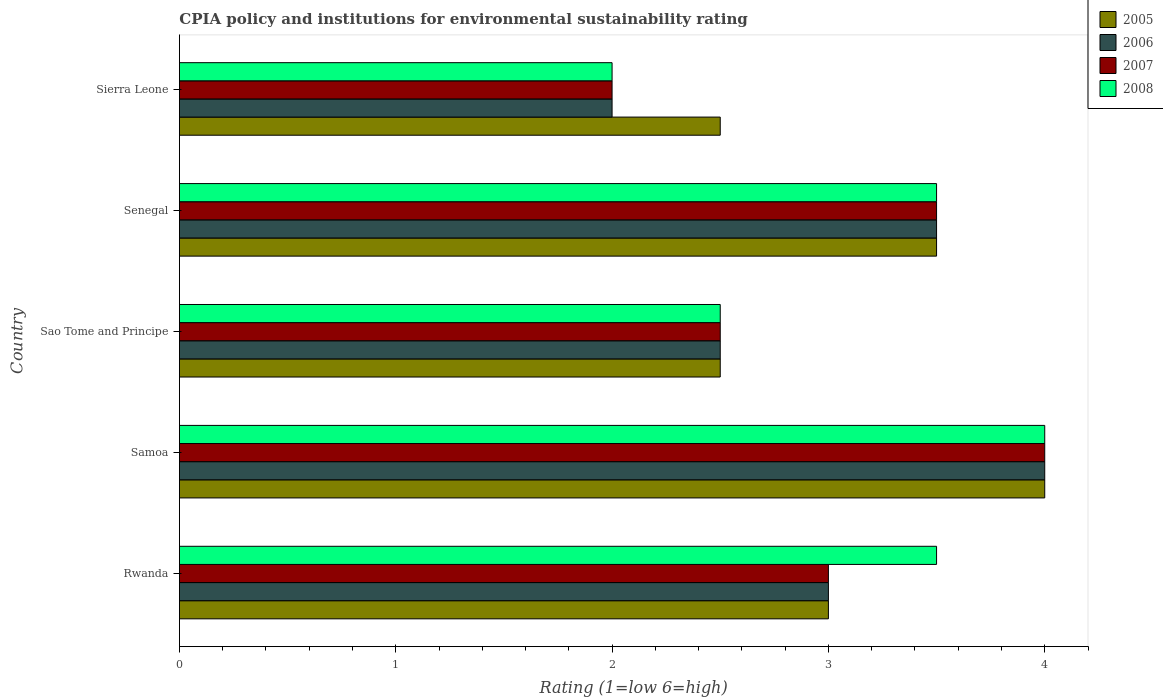How many bars are there on the 3rd tick from the bottom?
Give a very brief answer. 4. What is the label of the 2nd group of bars from the top?
Ensure brevity in your answer.  Senegal. What is the CPIA rating in 2008 in Sierra Leone?
Make the answer very short. 2. Across all countries, what is the maximum CPIA rating in 2008?
Provide a short and direct response. 4. In which country was the CPIA rating in 2007 maximum?
Keep it short and to the point. Samoa. In which country was the CPIA rating in 2006 minimum?
Your answer should be compact. Sierra Leone. What is the average CPIA rating in 2007 per country?
Provide a short and direct response. 3. What is the difference between the CPIA rating in 2005 and CPIA rating in 2008 in Rwanda?
Give a very brief answer. -0.5. In how many countries, is the CPIA rating in 2005 greater than 3.2 ?
Offer a terse response. 2. What is the difference between the highest and the second highest CPIA rating in 2008?
Make the answer very short. 0.5. What is the difference between the highest and the lowest CPIA rating in 2008?
Give a very brief answer. 2. In how many countries, is the CPIA rating in 2005 greater than the average CPIA rating in 2005 taken over all countries?
Provide a short and direct response. 2. Is the sum of the CPIA rating in 2006 in Rwanda and Samoa greater than the maximum CPIA rating in 2008 across all countries?
Make the answer very short. Yes. Is it the case that in every country, the sum of the CPIA rating in 2006 and CPIA rating in 2008 is greater than the sum of CPIA rating in 2007 and CPIA rating in 2005?
Offer a very short reply. No. Is it the case that in every country, the sum of the CPIA rating in 2007 and CPIA rating in 2006 is greater than the CPIA rating in 2005?
Provide a succinct answer. Yes. Are all the bars in the graph horizontal?
Offer a terse response. Yes. How many countries are there in the graph?
Your response must be concise. 5. What is the difference between two consecutive major ticks on the X-axis?
Keep it short and to the point. 1. Are the values on the major ticks of X-axis written in scientific E-notation?
Your answer should be very brief. No. Does the graph contain grids?
Ensure brevity in your answer.  No. Where does the legend appear in the graph?
Ensure brevity in your answer.  Top right. How many legend labels are there?
Ensure brevity in your answer.  4. How are the legend labels stacked?
Your response must be concise. Vertical. What is the title of the graph?
Provide a succinct answer. CPIA policy and institutions for environmental sustainability rating. Does "2015" appear as one of the legend labels in the graph?
Offer a very short reply. No. What is the label or title of the Y-axis?
Your answer should be very brief. Country. What is the Rating (1=low 6=high) of 2005 in Rwanda?
Give a very brief answer. 3. What is the Rating (1=low 6=high) of 2007 in Rwanda?
Keep it short and to the point. 3. What is the Rating (1=low 6=high) in 2008 in Rwanda?
Provide a succinct answer. 3.5. What is the Rating (1=low 6=high) in 2005 in Samoa?
Ensure brevity in your answer.  4. What is the Rating (1=low 6=high) in 2008 in Samoa?
Provide a succinct answer. 4. What is the Rating (1=low 6=high) in 2007 in Sao Tome and Principe?
Give a very brief answer. 2.5. What is the Rating (1=low 6=high) of 2006 in Senegal?
Your response must be concise. 3.5. What is the Rating (1=low 6=high) of 2007 in Senegal?
Your answer should be compact. 3.5. What is the Rating (1=low 6=high) in 2006 in Sierra Leone?
Offer a terse response. 2. Across all countries, what is the maximum Rating (1=low 6=high) in 2005?
Your response must be concise. 4. Across all countries, what is the maximum Rating (1=low 6=high) of 2007?
Provide a succinct answer. 4. Across all countries, what is the maximum Rating (1=low 6=high) of 2008?
Provide a short and direct response. 4. Across all countries, what is the minimum Rating (1=low 6=high) in 2005?
Your answer should be compact. 2.5. Across all countries, what is the minimum Rating (1=low 6=high) in 2006?
Keep it short and to the point. 2. Across all countries, what is the minimum Rating (1=low 6=high) in 2008?
Keep it short and to the point. 2. What is the total Rating (1=low 6=high) of 2006 in the graph?
Your answer should be compact. 15. What is the total Rating (1=low 6=high) in 2007 in the graph?
Provide a short and direct response. 15. What is the total Rating (1=low 6=high) in 2008 in the graph?
Your response must be concise. 15.5. What is the difference between the Rating (1=low 6=high) in 2006 in Rwanda and that in Samoa?
Your response must be concise. -1. What is the difference between the Rating (1=low 6=high) of 2007 in Rwanda and that in Sao Tome and Principe?
Provide a short and direct response. 0.5. What is the difference between the Rating (1=low 6=high) in 2008 in Rwanda and that in Sao Tome and Principe?
Ensure brevity in your answer.  1. What is the difference between the Rating (1=low 6=high) of 2007 in Rwanda and that in Senegal?
Ensure brevity in your answer.  -0.5. What is the difference between the Rating (1=low 6=high) of 2008 in Rwanda and that in Senegal?
Keep it short and to the point. 0. What is the difference between the Rating (1=low 6=high) of 2005 in Samoa and that in Sao Tome and Principe?
Keep it short and to the point. 1.5. What is the difference between the Rating (1=low 6=high) in 2007 in Samoa and that in Sao Tome and Principe?
Give a very brief answer. 1.5. What is the difference between the Rating (1=low 6=high) in 2005 in Samoa and that in Senegal?
Keep it short and to the point. 0.5. What is the difference between the Rating (1=low 6=high) in 2006 in Samoa and that in Senegal?
Give a very brief answer. 0.5. What is the difference between the Rating (1=low 6=high) of 2005 in Samoa and that in Sierra Leone?
Your response must be concise. 1.5. What is the difference between the Rating (1=low 6=high) of 2006 in Samoa and that in Sierra Leone?
Your response must be concise. 2. What is the difference between the Rating (1=low 6=high) of 2007 in Samoa and that in Sierra Leone?
Make the answer very short. 2. What is the difference between the Rating (1=low 6=high) in 2005 in Sao Tome and Principe and that in Senegal?
Your response must be concise. -1. What is the difference between the Rating (1=low 6=high) in 2006 in Sao Tome and Principe and that in Senegal?
Provide a succinct answer. -1. What is the difference between the Rating (1=low 6=high) of 2005 in Sao Tome and Principe and that in Sierra Leone?
Offer a very short reply. 0. What is the difference between the Rating (1=low 6=high) of 2006 in Sao Tome and Principe and that in Sierra Leone?
Give a very brief answer. 0.5. What is the difference between the Rating (1=low 6=high) of 2008 in Sao Tome and Principe and that in Sierra Leone?
Give a very brief answer. 0.5. What is the difference between the Rating (1=low 6=high) in 2006 in Senegal and that in Sierra Leone?
Offer a terse response. 1.5. What is the difference between the Rating (1=low 6=high) of 2005 in Rwanda and the Rating (1=low 6=high) of 2006 in Samoa?
Ensure brevity in your answer.  -1. What is the difference between the Rating (1=low 6=high) of 2005 in Rwanda and the Rating (1=low 6=high) of 2007 in Samoa?
Ensure brevity in your answer.  -1. What is the difference between the Rating (1=low 6=high) of 2005 in Rwanda and the Rating (1=low 6=high) of 2008 in Samoa?
Provide a succinct answer. -1. What is the difference between the Rating (1=low 6=high) in 2006 in Rwanda and the Rating (1=low 6=high) in 2008 in Samoa?
Your answer should be compact. -1. What is the difference between the Rating (1=low 6=high) of 2005 in Rwanda and the Rating (1=low 6=high) of 2007 in Sao Tome and Principe?
Give a very brief answer. 0.5. What is the difference between the Rating (1=low 6=high) of 2006 in Rwanda and the Rating (1=low 6=high) of 2007 in Sao Tome and Principe?
Offer a very short reply. 0.5. What is the difference between the Rating (1=low 6=high) of 2005 in Rwanda and the Rating (1=low 6=high) of 2006 in Senegal?
Your response must be concise. -0.5. What is the difference between the Rating (1=low 6=high) of 2005 in Rwanda and the Rating (1=low 6=high) of 2008 in Senegal?
Offer a terse response. -0.5. What is the difference between the Rating (1=low 6=high) of 2006 in Rwanda and the Rating (1=low 6=high) of 2007 in Senegal?
Offer a terse response. -0.5. What is the difference between the Rating (1=low 6=high) of 2006 in Rwanda and the Rating (1=low 6=high) of 2008 in Senegal?
Ensure brevity in your answer.  -0.5. What is the difference between the Rating (1=low 6=high) of 2005 in Rwanda and the Rating (1=low 6=high) of 2006 in Sierra Leone?
Provide a succinct answer. 1. What is the difference between the Rating (1=low 6=high) in 2005 in Samoa and the Rating (1=low 6=high) in 2006 in Sao Tome and Principe?
Ensure brevity in your answer.  1.5. What is the difference between the Rating (1=low 6=high) in 2005 in Samoa and the Rating (1=low 6=high) in 2007 in Sao Tome and Principe?
Provide a succinct answer. 1.5. What is the difference between the Rating (1=low 6=high) in 2006 in Samoa and the Rating (1=low 6=high) in 2008 in Sao Tome and Principe?
Provide a short and direct response. 1.5. What is the difference between the Rating (1=low 6=high) of 2007 in Samoa and the Rating (1=low 6=high) of 2008 in Sao Tome and Principe?
Offer a very short reply. 1.5. What is the difference between the Rating (1=low 6=high) of 2005 in Samoa and the Rating (1=low 6=high) of 2007 in Senegal?
Provide a succinct answer. 0.5. What is the difference between the Rating (1=low 6=high) in 2006 in Samoa and the Rating (1=low 6=high) in 2007 in Senegal?
Give a very brief answer. 0.5. What is the difference between the Rating (1=low 6=high) of 2005 in Samoa and the Rating (1=low 6=high) of 2008 in Sierra Leone?
Your response must be concise. 2. What is the difference between the Rating (1=low 6=high) of 2005 in Sao Tome and Principe and the Rating (1=low 6=high) of 2007 in Senegal?
Make the answer very short. -1. What is the difference between the Rating (1=low 6=high) in 2005 in Sao Tome and Principe and the Rating (1=low 6=high) in 2008 in Senegal?
Give a very brief answer. -1. What is the difference between the Rating (1=low 6=high) in 2005 in Sao Tome and Principe and the Rating (1=low 6=high) in 2007 in Sierra Leone?
Provide a succinct answer. 0.5. What is the difference between the Rating (1=low 6=high) in 2006 in Sao Tome and Principe and the Rating (1=low 6=high) in 2007 in Sierra Leone?
Provide a short and direct response. 0.5. What is the difference between the Rating (1=low 6=high) in 2005 in Senegal and the Rating (1=low 6=high) in 2006 in Sierra Leone?
Provide a succinct answer. 1.5. What is the difference between the Rating (1=low 6=high) in 2005 in Senegal and the Rating (1=low 6=high) in 2008 in Sierra Leone?
Offer a very short reply. 1.5. What is the difference between the Rating (1=low 6=high) of 2006 in Senegal and the Rating (1=low 6=high) of 2007 in Sierra Leone?
Provide a succinct answer. 1.5. What is the difference between the Rating (1=low 6=high) of 2006 in Senegal and the Rating (1=low 6=high) of 2008 in Sierra Leone?
Keep it short and to the point. 1.5. What is the difference between the Rating (1=low 6=high) of 2007 in Senegal and the Rating (1=low 6=high) of 2008 in Sierra Leone?
Provide a short and direct response. 1.5. What is the average Rating (1=low 6=high) of 2006 per country?
Make the answer very short. 3. What is the difference between the Rating (1=low 6=high) of 2005 and Rating (1=low 6=high) of 2006 in Rwanda?
Your answer should be very brief. 0. What is the difference between the Rating (1=low 6=high) in 2005 and Rating (1=low 6=high) in 2007 in Rwanda?
Make the answer very short. 0. What is the difference between the Rating (1=low 6=high) of 2006 and Rating (1=low 6=high) of 2007 in Rwanda?
Offer a very short reply. 0. What is the difference between the Rating (1=low 6=high) of 2007 and Rating (1=low 6=high) of 2008 in Rwanda?
Offer a very short reply. -0.5. What is the difference between the Rating (1=low 6=high) in 2005 and Rating (1=low 6=high) in 2007 in Samoa?
Your answer should be compact. 0. What is the difference between the Rating (1=low 6=high) in 2005 and Rating (1=low 6=high) in 2008 in Samoa?
Ensure brevity in your answer.  0. What is the difference between the Rating (1=low 6=high) in 2007 and Rating (1=low 6=high) in 2008 in Samoa?
Keep it short and to the point. 0. What is the difference between the Rating (1=low 6=high) of 2005 and Rating (1=low 6=high) of 2006 in Sao Tome and Principe?
Provide a short and direct response. 0. What is the difference between the Rating (1=low 6=high) of 2005 and Rating (1=low 6=high) of 2007 in Sao Tome and Principe?
Your answer should be compact. 0. What is the difference between the Rating (1=low 6=high) of 2005 and Rating (1=low 6=high) of 2008 in Sao Tome and Principe?
Offer a very short reply. 0. What is the difference between the Rating (1=low 6=high) in 2006 and Rating (1=low 6=high) in 2008 in Senegal?
Provide a succinct answer. 0. What is the difference between the Rating (1=low 6=high) of 2007 and Rating (1=low 6=high) of 2008 in Senegal?
Give a very brief answer. 0. What is the difference between the Rating (1=low 6=high) in 2005 and Rating (1=low 6=high) in 2006 in Sierra Leone?
Keep it short and to the point. 0.5. What is the difference between the Rating (1=low 6=high) of 2005 and Rating (1=low 6=high) of 2008 in Sierra Leone?
Offer a terse response. 0.5. What is the difference between the Rating (1=low 6=high) in 2006 and Rating (1=low 6=high) in 2008 in Sierra Leone?
Offer a terse response. 0. What is the difference between the Rating (1=low 6=high) in 2007 and Rating (1=low 6=high) in 2008 in Sierra Leone?
Provide a succinct answer. 0. What is the ratio of the Rating (1=low 6=high) in 2005 in Rwanda to that in Samoa?
Your answer should be compact. 0.75. What is the ratio of the Rating (1=low 6=high) of 2006 in Rwanda to that in Samoa?
Keep it short and to the point. 0.75. What is the ratio of the Rating (1=low 6=high) in 2006 in Rwanda to that in Sao Tome and Principe?
Offer a very short reply. 1.2. What is the ratio of the Rating (1=low 6=high) of 2006 in Rwanda to that in Senegal?
Your answer should be compact. 0.86. What is the ratio of the Rating (1=low 6=high) in 2008 in Rwanda to that in Senegal?
Offer a very short reply. 1. What is the ratio of the Rating (1=low 6=high) in 2006 in Rwanda to that in Sierra Leone?
Your answer should be very brief. 1.5. What is the ratio of the Rating (1=low 6=high) in 2007 in Rwanda to that in Sierra Leone?
Your answer should be very brief. 1.5. What is the ratio of the Rating (1=low 6=high) of 2008 in Rwanda to that in Sierra Leone?
Offer a terse response. 1.75. What is the ratio of the Rating (1=low 6=high) of 2007 in Samoa to that in Sao Tome and Principe?
Your answer should be compact. 1.6. What is the ratio of the Rating (1=low 6=high) in 2007 in Samoa to that in Senegal?
Make the answer very short. 1.14. What is the ratio of the Rating (1=low 6=high) in 2008 in Samoa to that in Senegal?
Offer a terse response. 1.14. What is the ratio of the Rating (1=low 6=high) of 2006 in Samoa to that in Sierra Leone?
Give a very brief answer. 2. What is the ratio of the Rating (1=low 6=high) in 2008 in Samoa to that in Sierra Leone?
Your response must be concise. 2. What is the ratio of the Rating (1=low 6=high) of 2005 in Sao Tome and Principe to that in Senegal?
Give a very brief answer. 0.71. What is the ratio of the Rating (1=low 6=high) of 2007 in Sao Tome and Principe to that in Senegal?
Ensure brevity in your answer.  0.71. What is the ratio of the Rating (1=low 6=high) of 2006 in Sao Tome and Principe to that in Sierra Leone?
Make the answer very short. 1.25. What is the ratio of the Rating (1=low 6=high) of 2008 in Sao Tome and Principe to that in Sierra Leone?
Your answer should be very brief. 1.25. What is the ratio of the Rating (1=low 6=high) of 2005 in Senegal to that in Sierra Leone?
Provide a succinct answer. 1.4. What is the ratio of the Rating (1=low 6=high) in 2007 in Senegal to that in Sierra Leone?
Offer a terse response. 1.75. What is the ratio of the Rating (1=low 6=high) in 2008 in Senegal to that in Sierra Leone?
Give a very brief answer. 1.75. What is the difference between the highest and the second highest Rating (1=low 6=high) of 2005?
Provide a succinct answer. 0.5. What is the difference between the highest and the lowest Rating (1=low 6=high) of 2007?
Offer a terse response. 2. What is the difference between the highest and the lowest Rating (1=low 6=high) of 2008?
Offer a terse response. 2. 